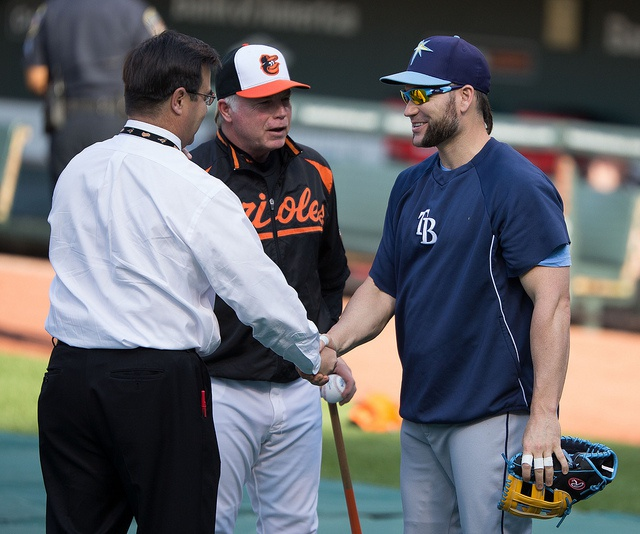Describe the objects in this image and their specific colors. I can see people in black, lavender, darkgray, and gray tones, people in black, navy, darkgray, and tan tones, people in black, lavender, brown, and salmon tones, people in black and gray tones, and baseball glove in black, olive, blue, and navy tones in this image. 